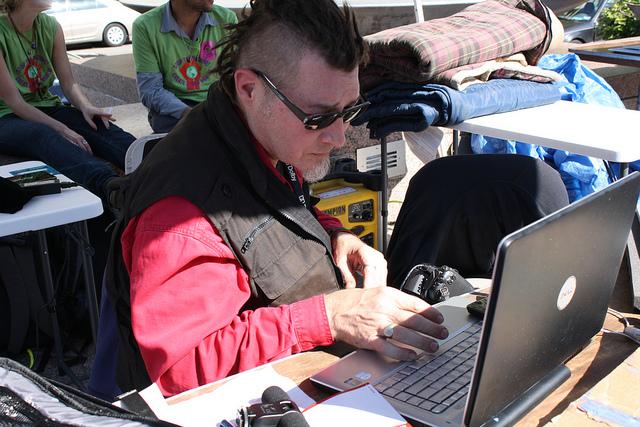What brand is the laptop?
Short answer required. Dell. What jewelry is the man wearing?
Write a very short answer. Ring. Does he look mad?
Answer briefly. No. 